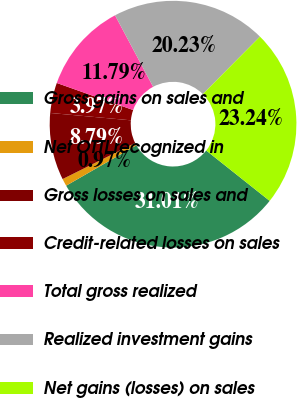<chart> <loc_0><loc_0><loc_500><loc_500><pie_chart><fcel>Gross gains on sales and<fcel>Net OTTI recognized in<fcel>Gross losses on sales and<fcel>Credit-related losses on sales<fcel>Total gross realized<fcel>Realized investment gains<fcel>Net gains (losses) on sales<nl><fcel>31.01%<fcel>0.97%<fcel>8.79%<fcel>3.97%<fcel>11.79%<fcel>20.23%<fcel>23.24%<nl></chart> 